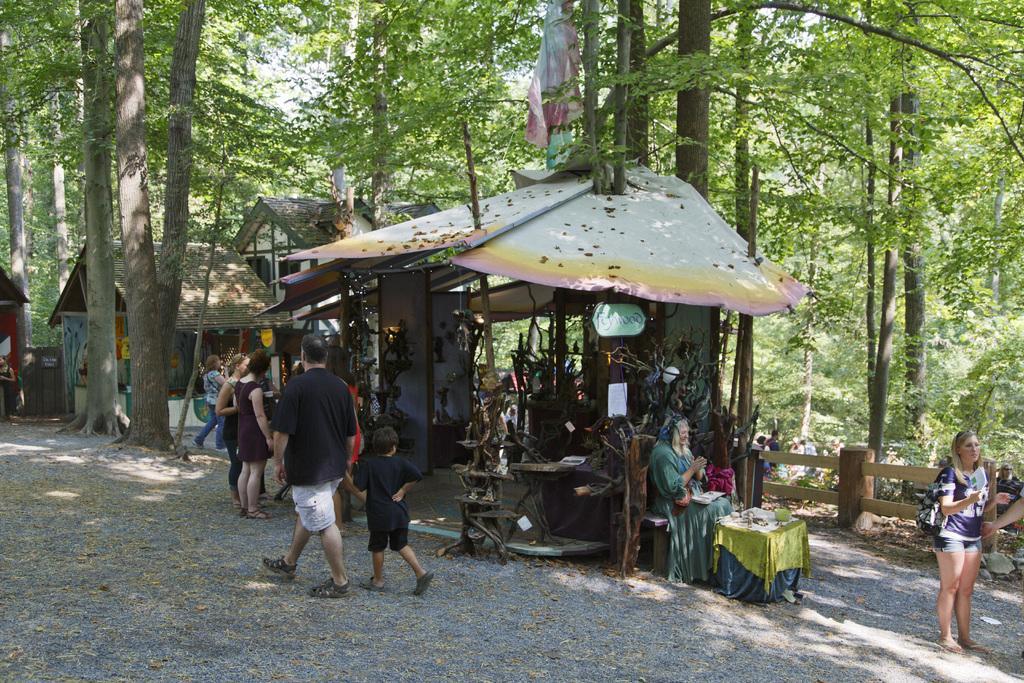Could you give a brief overview of what you see in this image? Here a man is walking, he wore a black color t-shirt. He is also holding a child, in the right side a woman is standing, these are the trees. 